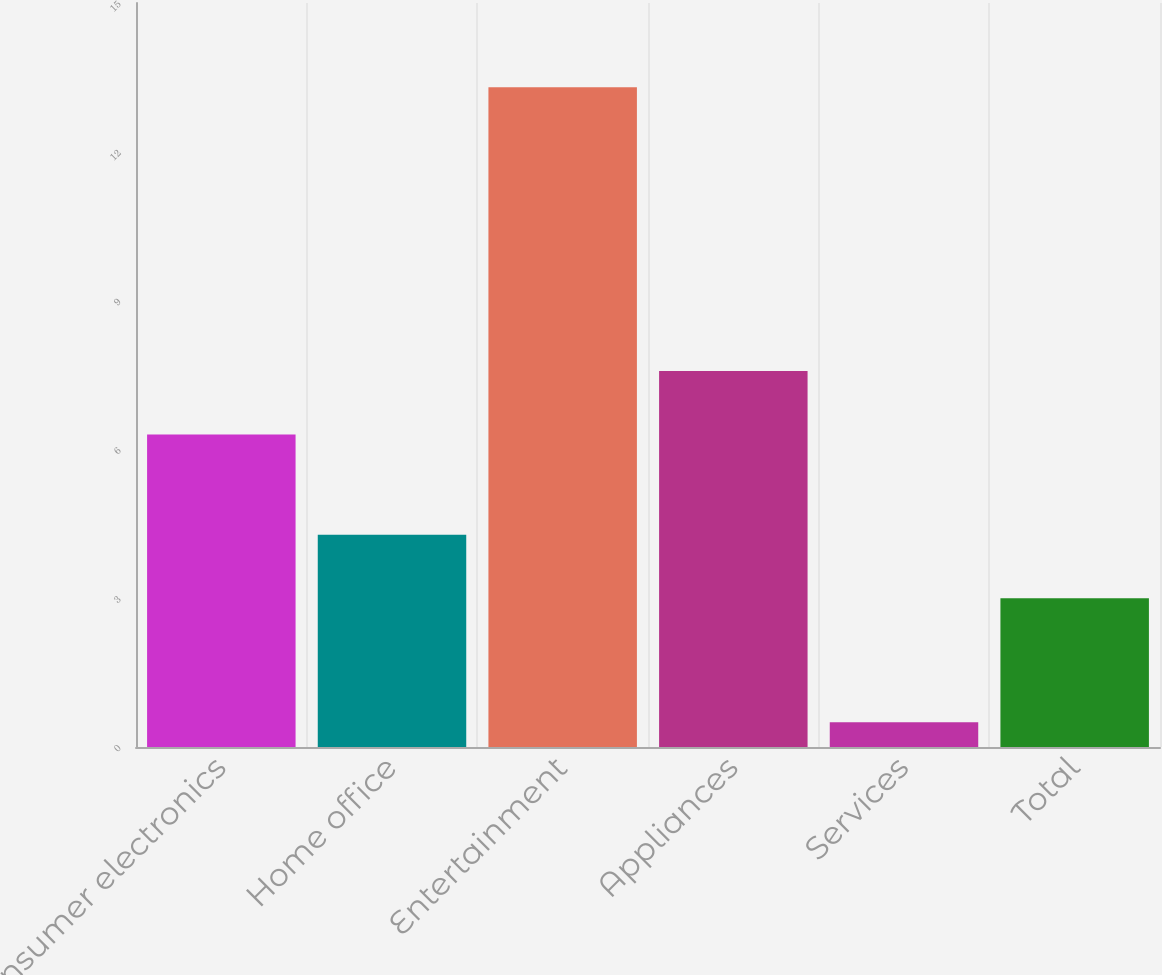<chart> <loc_0><loc_0><loc_500><loc_500><bar_chart><fcel>Consumer electronics<fcel>Home office<fcel>Entertainment<fcel>Appliances<fcel>Services<fcel>Total<nl><fcel>6.3<fcel>4.28<fcel>13.3<fcel>7.58<fcel>0.5<fcel>3<nl></chart> 